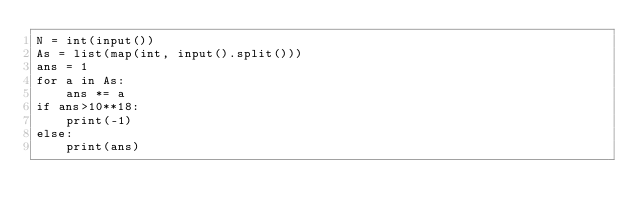Convert code to text. <code><loc_0><loc_0><loc_500><loc_500><_Python_>N = int(input())
As = list(map(int, input().split()))
ans = 1
for a in As:
    ans *= a
if ans>10**18:
    print(-1)
else:
    print(ans)</code> 